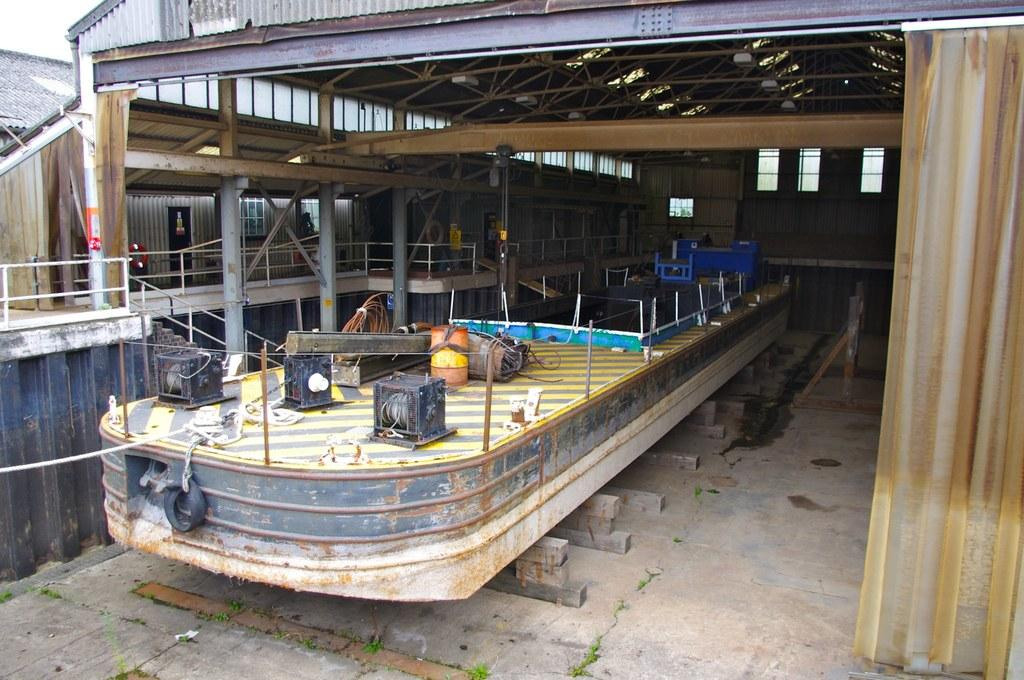What type of structure can be seen in the image? There is a shed and a building in the image. What other objects are present in the image? There are poles, lights, metal rods, windows, and an object that looks like a boat in the image. Can you see the crown on the king's head in the image? There is no text or king mentioned in the image, and therefore no crown can be seen. 